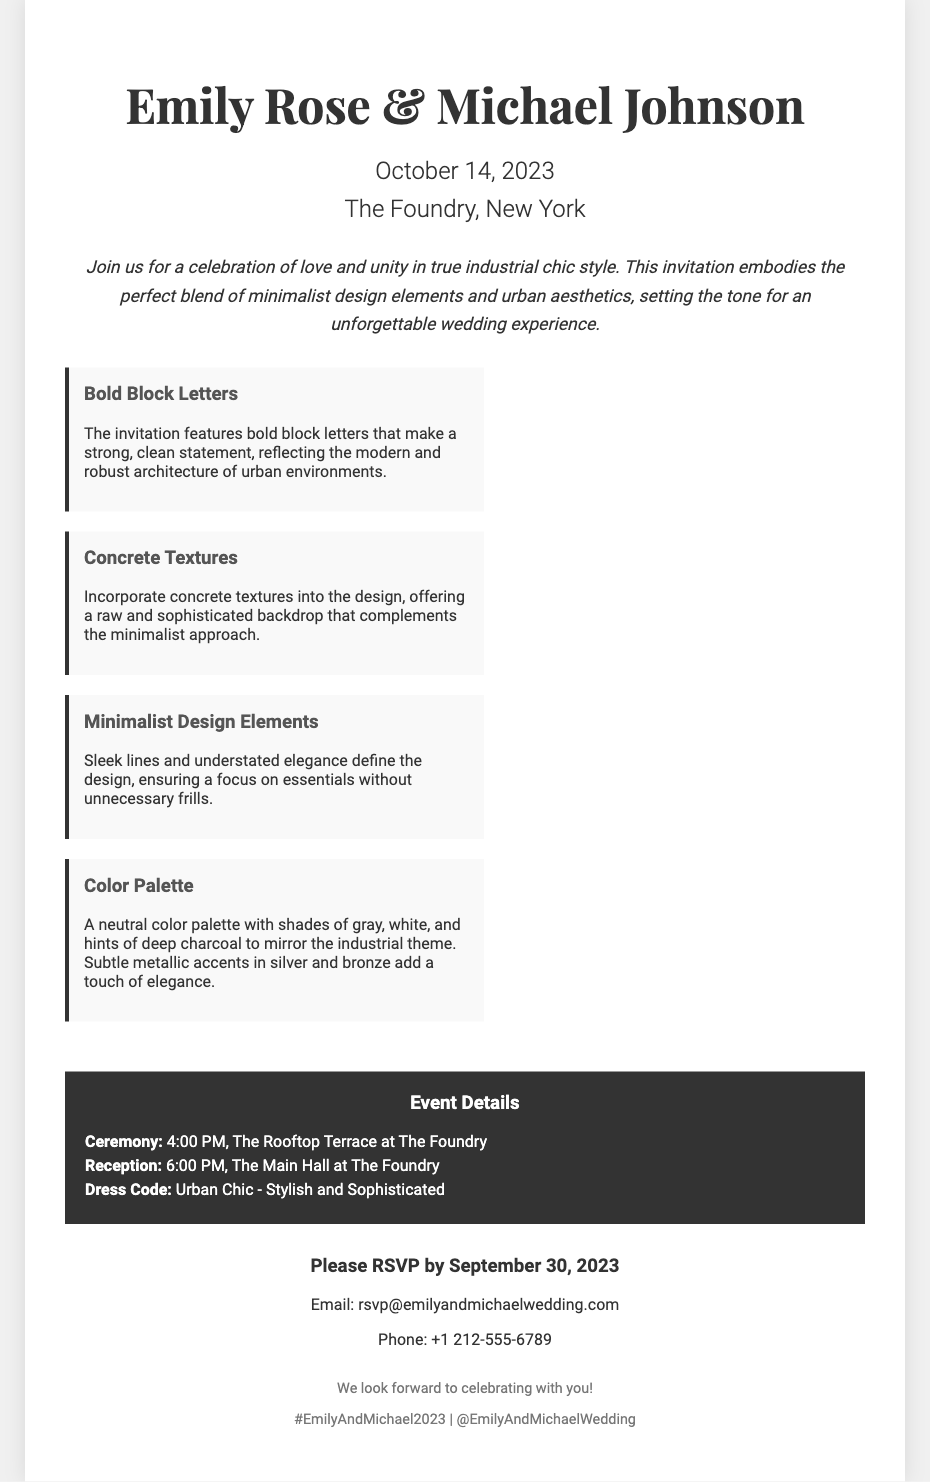What are the names of the couple? The names of the couple are mentioned prominently at the top of the invitation.
Answer: Emily Rose & Michael Johnson When is the wedding date? The wedding date is specified in the header section of the invitation.
Answer: October 14, 2023 Where is the wedding venue? The venue is listed in the header section, stating the location of the event.
Answer: The Foundry, New York What is the dress code? The dress code is detailed in the event details section of the invitation.
Answer: Urban Chic - Stylish and Sophisticated What are the RSVP contact details? The RSVP section provides specific contact information for guests.
Answer: rsvp@emilyandmichaelwedding.com What design element is highlighted in bold letters? The invitation specifically mentions the bold letters as a design feature.
Answer: Bold Block Letters What is the main color palette used? The color palette is described in the features section, detailing the theme colors chosen.
Answer: Shades of gray, white, and hints of deep charcoal What is the time for the ceremony? The event details section states the specific time for the ceremony.
Answer: 4:00 PM What feature complements the minimalist approach? The feature section mentions specific design elements that embody the minimalist style.
Answer: Concrete Textures 